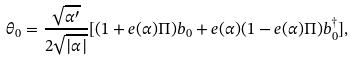Convert formula to latex. <formula><loc_0><loc_0><loc_500><loc_500>\theta _ { 0 } = \frac { \sqrt { \alpha ^ { \prime } } } { 2 \sqrt { | \alpha | } } [ ( 1 + e ( \alpha ) \Pi ) b _ { 0 } + e ( \alpha ) ( 1 - e ( \alpha ) \Pi ) b _ { 0 } ^ { \dagger } ] ,</formula> 